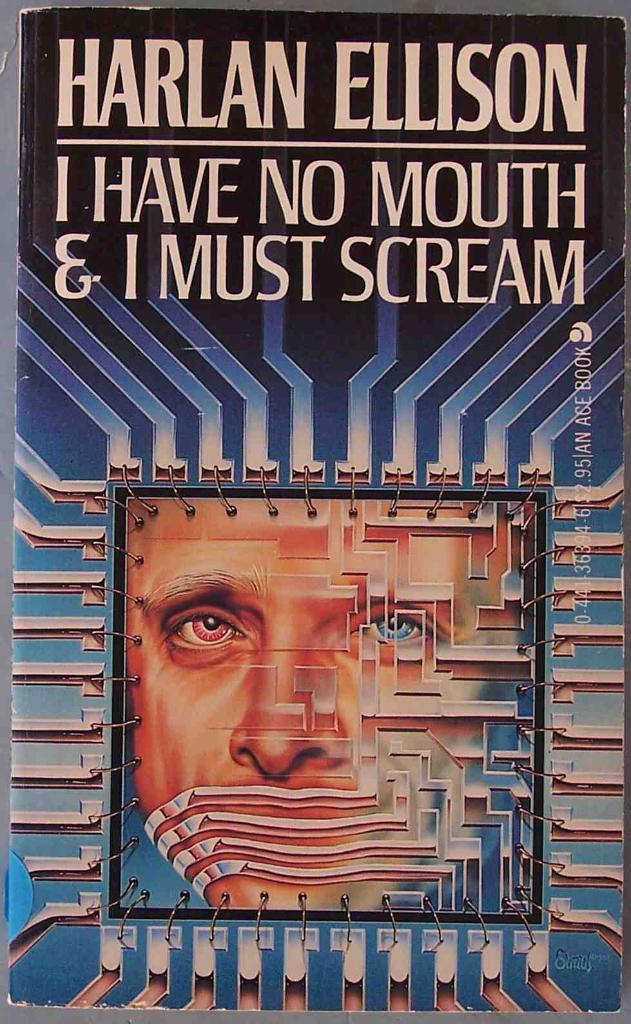What type of publication is visible in the image? There is a magazine in the image. What is the title of the magazine? The magazine has the title "HARLAN ELLISON- I have no mouth and I must scream." How much powder is visible on the cover of the magazine in the image? There is no powder visible on the cover of the magazine in the image. Are there any ants crawling on the magazine in the image? There are no ants visible on the magazine in the image. 